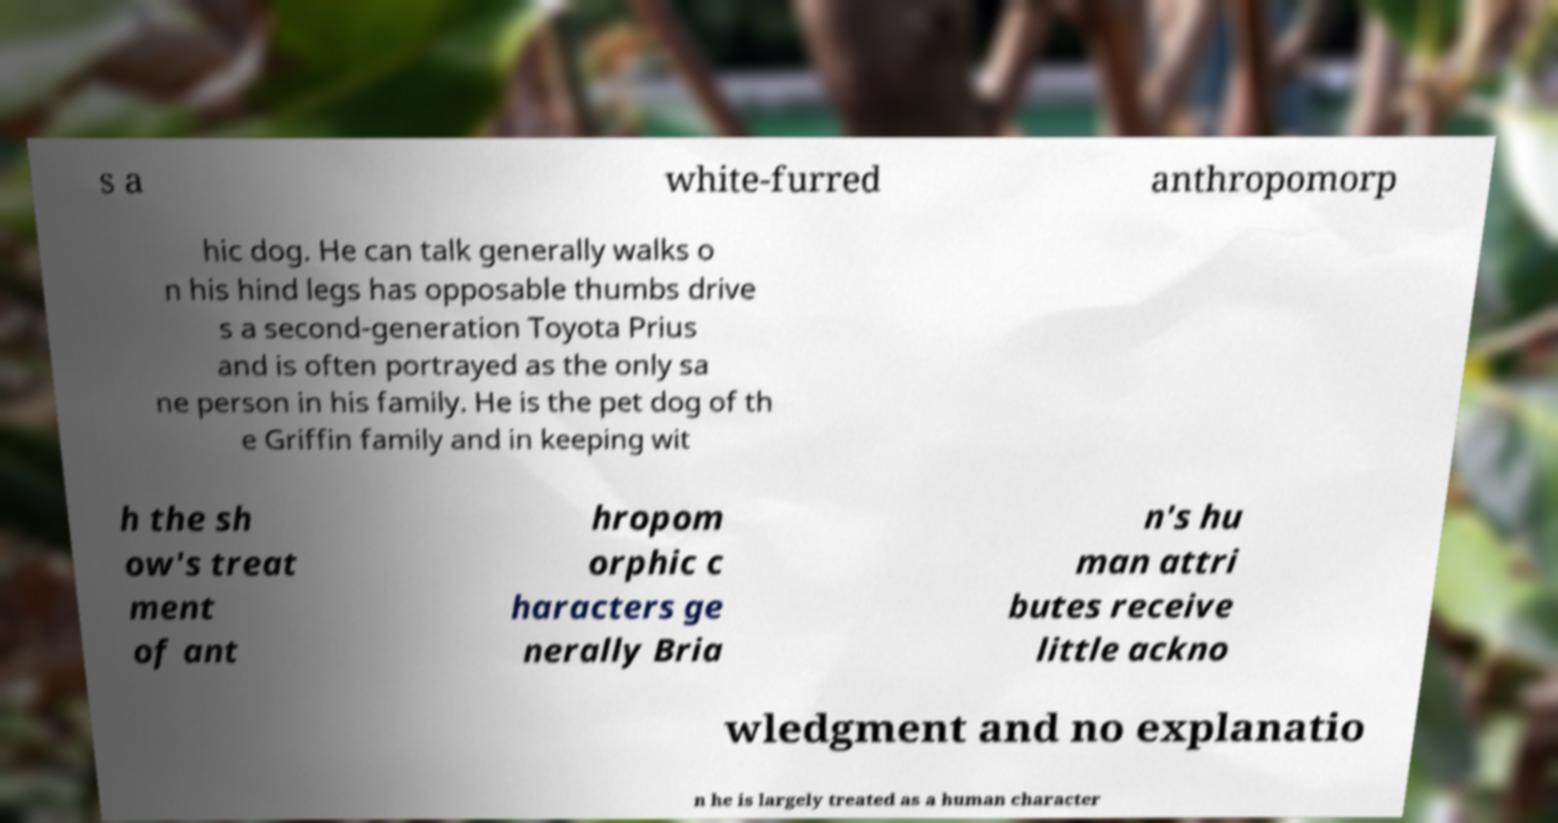What messages or text are displayed in this image? I need them in a readable, typed format. s a white-furred anthropomorp hic dog. He can talk generally walks o n his hind legs has opposable thumbs drive s a second-generation Toyota Prius and is often portrayed as the only sa ne person in his family. He is the pet dog of th e Griffin family and in keeping wit h the sh ow's treat ment of ant hropom orphic c haracters ge nerally Bria n's hu man attri butes receive little ackno wledgment and no explanatio n he is largely treated as a human character 